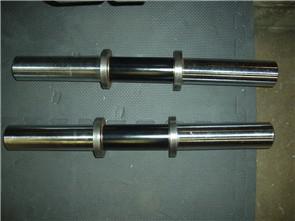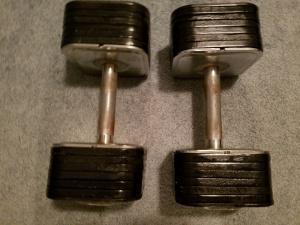The first image is the image on the left, the second image is the image on the right. For the images shown, is this caption "There are exactly four objects." true? Answer yes or no. Yes. 